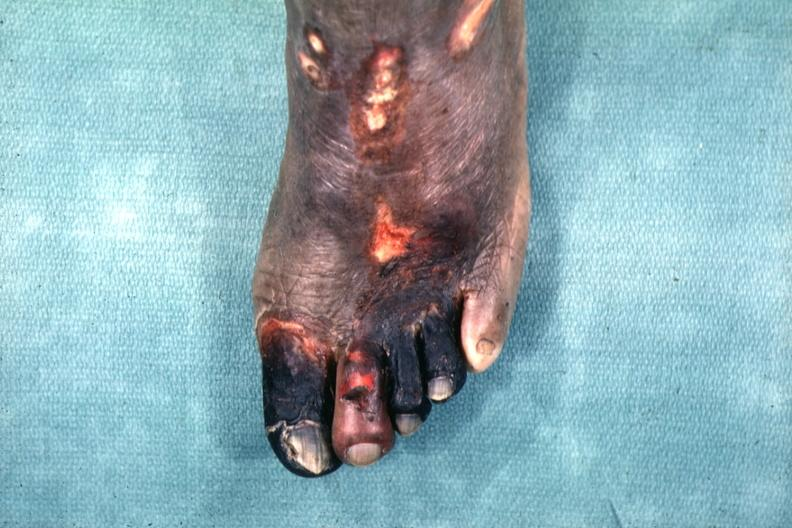does omentum show excellent example of gangrene of the first four toes?
Answer the question using a single word or phrase. No 